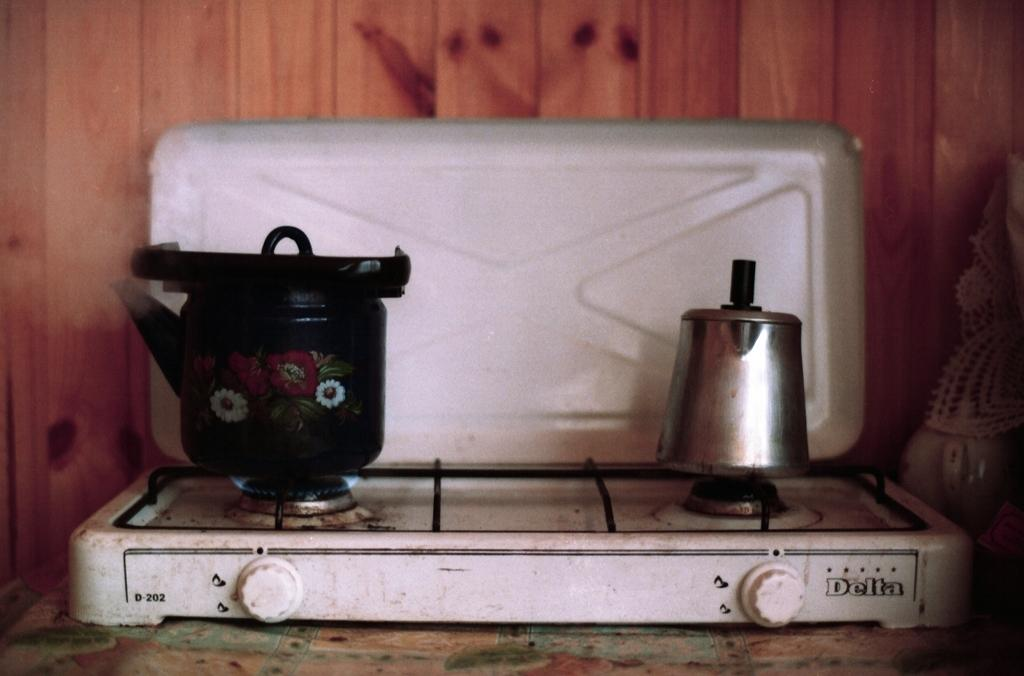<image>
Write a terse but informative summary of the picture. white delta d-202 gas cooktop with a coffepot and a blue flowered kettle on it 